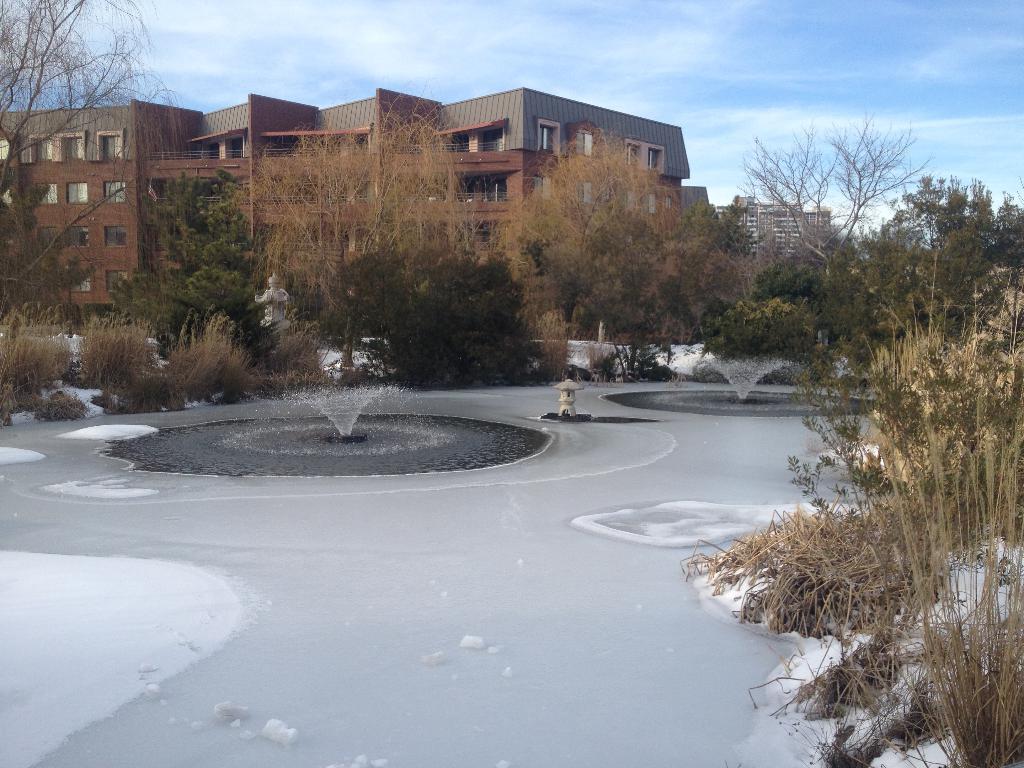Can you describe this image briefly? In this picture we can see ice, water, statue, trees, buildings with windows and some objects and in the background we can see the sky. 